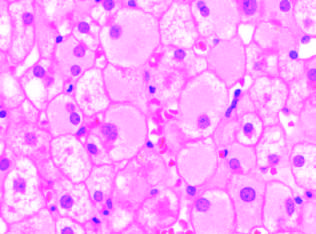what show diffuse granular cyto-plasm, reflecting accumulated hepatitis b surface antigen hbsag in chronic infections?
Answer the question using a single word or phrase. Infected hepatocytes 